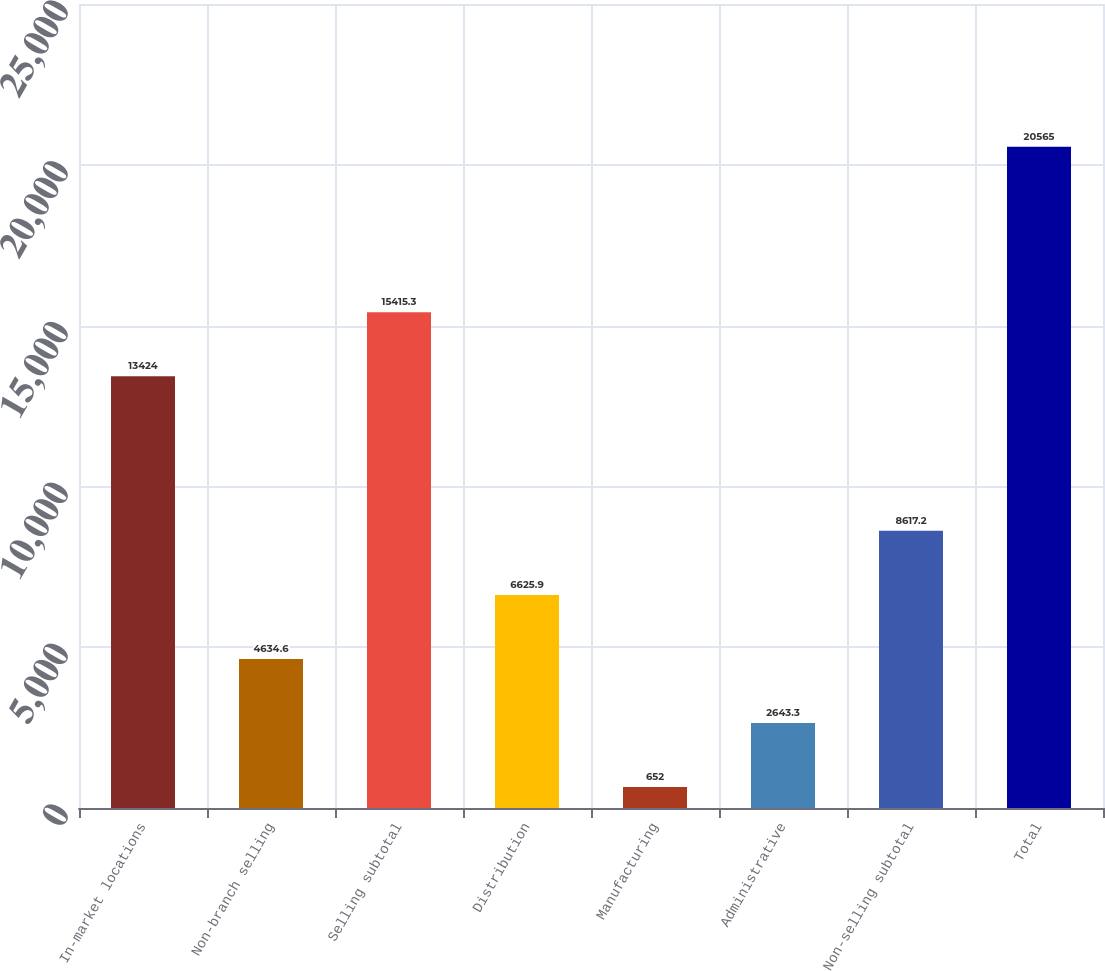Convert chart. <chart><loc_0><loc_0><loc_500><loc_500><bar_chart><fcel>In-market locations<fcel>Non-branch selling<fcel>Selling subtotal<fcel>Distribution<fcel>Manufacturing<fcel>Administrative<fcel>Non-selling subtotal<fcel>Total<nl><fcel>13424<fcel>4634.6<fcel>15415.3<fcel>6625.9<fcel>652<fcel>2643.3<fcel>8617.2<fcel>20565<nl></chart> 